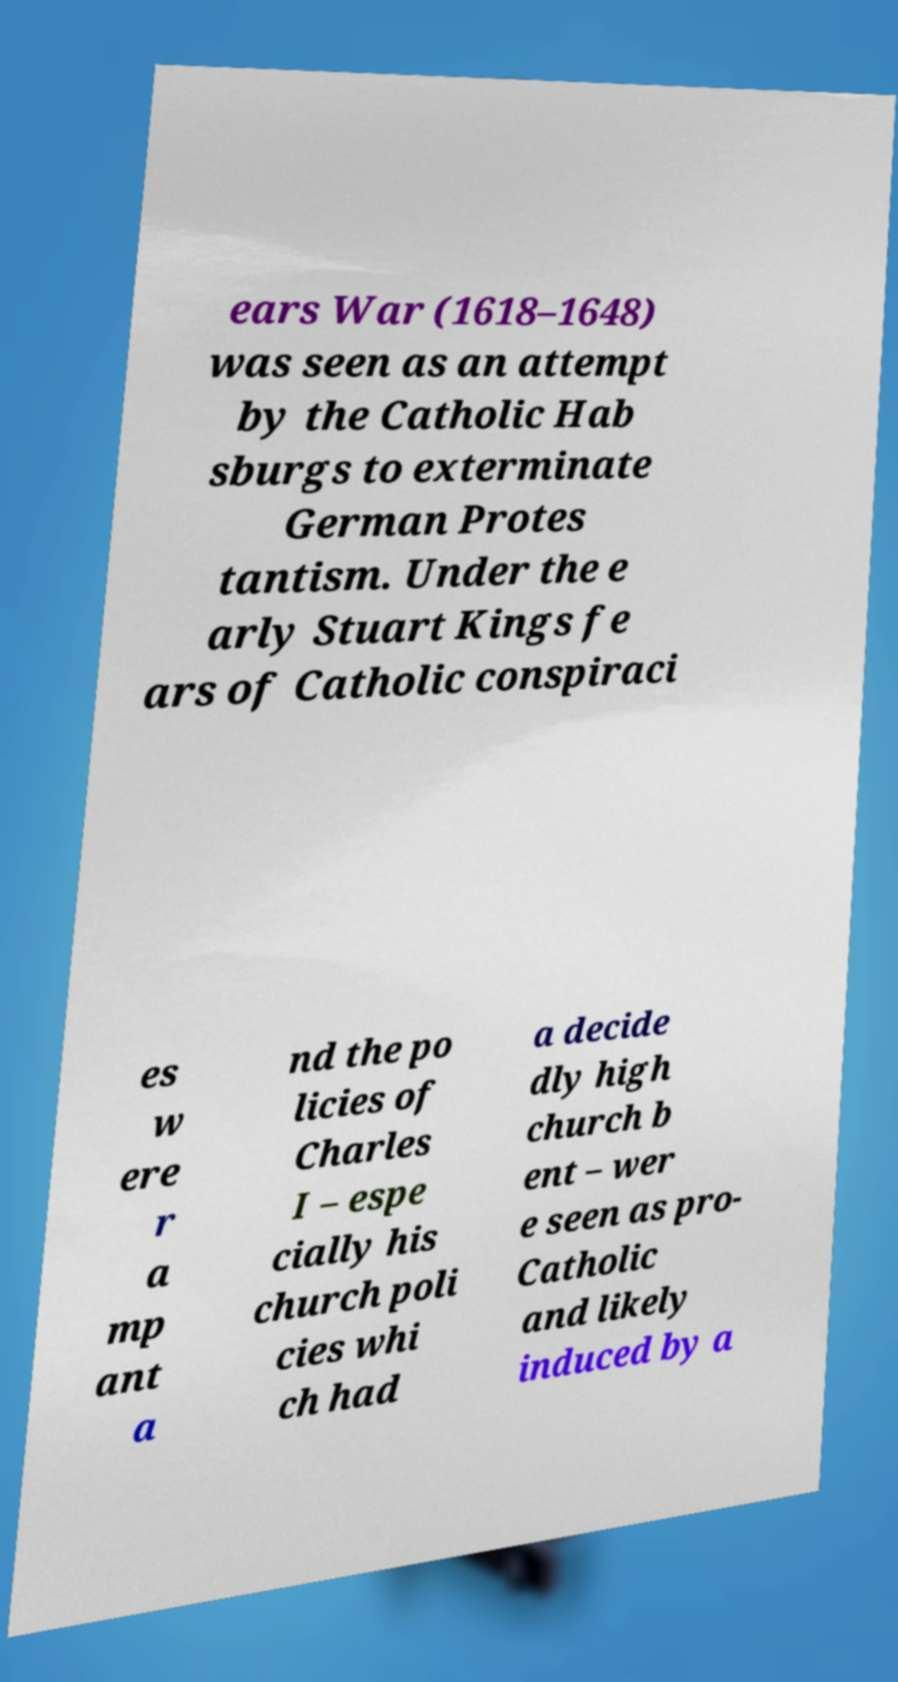Could you assist in decoding the text presented in this image and type it out clearly? ears War (1618–1648) was seen as an attempt by the Catholic Hab sburgs to exterminate German Protes tantism. Under the e arly Stuart Kings fe ars of Catholic conspiraci es w ere r a mp ant a nd the po licies of Charles I – espe cially his church poli cies whi ch had a decide dly high church b ent – wer e seen as pro- Catholic and likely induced by a 